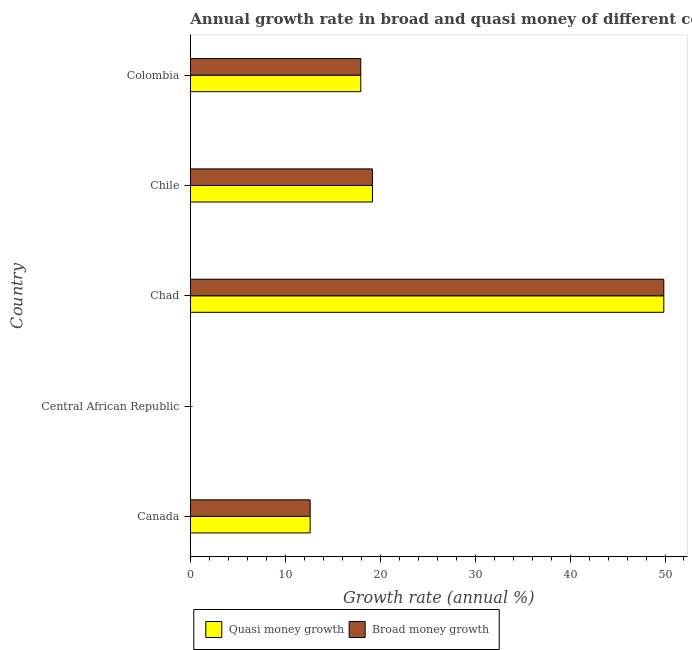Are the number of bars on each tick of the Y-axis equal?
Provide a short and direct response. No. How many bars are there on the 2nd tick from the top?
Keep it short and to the point. 2. What is the label of the 3rd group of bars from the top?
Offer a terse response. Chad. In how many cases, is the number of bars for a given country not equal to the number of legend labels?
Offer a very short reply. 1. What is the annual growth rate in quasi money in Central African Republic?
Give a very brief answer. 0. Across all countries, what is the maximum annual growth rate in broad money?
Make the answer very short. 49.88. In which country was the annual growth rate in quasi money maximum?
Ensure brevity in your answer.  Chad. What is the total annual growth rate in broad money in the graph?
Keep it short and to the point. 99.64. What is the difference between the annual growth rate in broad money in Canada and that in Chad?
Offer a terse response. -37.25. What is the difference between the annual growth rate in quasi money in Colombia and the annual growth rate in broad money in Canada?
Keep it short and to the point. 5.33. What is the average annual growth rate in broad money per country?
Offer a terse response. 19.93. What is the ratio of the annual growth rate in quasi money in Chile to that in Colombia?
Your answer should be very brief. 1.07. Is the annual growth rate in broad money in Canada less than that in Colombia?
Provide a succinct answer. Yes. What is the difference between the highest and the second highest annual growth rate in quasi money?
Offer a terse response. 30.69. What is the difference between the highest and the lowest annual growth rate in quasi money?
Your answer should be compact. 49.88. In how many countries, is the annual growth rate in broad money greater than the average annual growth rate in broad money taken over all countries?
Your answer should be very brief. 1. Is the sum of the annual growth rate in quasi money in Chad and Chile greater than the maximum annual growth rate in broad money across all countries?
Provide a succinct answer. Yes. How many countries are there in the graph?
Offer a terse response. 5. What is the difference between two consecutive major ticks on the X-axis?
Keep it short and to the point. 10. Does the graph contain grids?
Offer a terse response. No. How many legend labels are there?
Your response must be concise. 2. What is the title of the graph?
Ensure brevity in your answer.  Annual growth rate in broad and quasi money of different countries. Does "Passenger Transport Items" appear as one of the legend labels in the graph?
Keep it short and to the point. No. What is the label or title of the X-axis?
Offer a terse response. Growth rate (annual %). What is the Growth rate (annual %) in Quasi money growth in Canada?
Offer a terse response. 12.63. What is the Growth rate (annual %) in Broad money growth in Canada?
Make the answer very short. 12.63. What is the Growth rate (annual %) of Quasi money growth in Central African Republic?
Provide a short and direct response. 0. What is the Growth rate (annual %) in Broad money growth in Central African Republic?
Your response must be concise. 0. What is the Growth rate (annual %) of Quasi money growth in Chad?
Your answer should be compact. 49.88. What is the Growth rate (annual %) of Broad money growth in Chad?
Make the answer very short. 49.88. What is the Growth rate (annual %) in Quasi money growth in Chile?
Your answer should be compact. 19.19. What is the Growth rate (annual %) in Broad money growth in Chile?
Offer a very short reply. 19.19. What is the Growth rate (annual %) of Quasi money growth in Colombia?
Make the answer very short. 17.95. What is the Growth rate (annual %) of Broad money growth in Colombia?
Give a very brief answer. 17.95. Across all countries, what is the maximum Growth rate (annual %) in Quasi money growth?
Provide a short and direct response. 49.88. Across all countries, what is the maximum Growth rate (annual %) in Broad money growth?
Make the answer very short. 49.88. Across all countries, what is the minimum Growth rate (annual %) in Broad money growth?
Provide a short and direct response. 0. What is the total Growth rate (annual %) of Quasi money growth in the graph?
Offer a terse response. 99.64. What is the total Growth rate (annual %) in Broad money growth in the graph?
Offer a terse response. 99.64. What is the difference between the Growth rate (annual %) in Quasi money growth in Canada and that in Chad?
Offer a terse response. -37.25. What is the difference between the Growth rate (annual %) of Broad money growth in Canada and that in Chad?
Your response must be concise. -37.25. What is the difference between the Growth rate (annual %) of Quasi money growth in Canada and that in Chile?
Ensure brevity in your answer.  -6.56. What is the difference between the Growth rate (annual %) of Broad money growth in Canada and that in Chile?
Make the answer very short. -6.56. What is the difference between the Growth rate (annual %) in Quasi money growth in Canada and that in Colombia?
Offer a very short reply. -5.33. What is the difference between the Growth rate (annual %) in Broad money growth in Canada and that in Colombia?
Make the answer very short. -5.33. What is the difference between the Growth rate (annual %) in Quasi money growth in Chad and that in Chile?
Keep it short and to the point. 30.69. What is the difference between the Growth rate (annual %) in Broad money growth in Chad and that in Chile?
Offer a terse response. 30.69. What is the difference between the Growth rate (annual %) in Quasi money growth in Chad and that in Colombia?
Ensure brevity in your answer.  31.92. What is the difference between the Growth rate (annual %) of Broad money growth in Chad and that in Colombia?
Your answer should be compact. 31.92. What is the difference between the Growth rate (annual %) in Quasi money growth in Chile and that in Colombia?
Provide a succinct answer. 1.23. What is the difference between the Growth rate (annual %) of Broad money growth in Chile and that in Colombia?
Your response must be concise. 1.23. What is the difference between the Growth rate (annual %) of Quasi money growth in Canada and the Growth rate (annual %) of Broad money growth in Chad?
Your answer should be very brief. -37.25. What is the difference between the Growth rate (annual %) of Quasi money growth in Canada and the Growth rate (annual %) of Broad money growth in Chile?
Keep it short and to the point. -6.56. What is the difference between the Growth rate (annual %) in Quasi money growth in Canada and the Growth rate (annual %) in Broad money growth in Colombia?
Offer a very short reply. -5.33. What is the difference between the Growth rate (annual %) in Quasi money growth in Chad and the Growth rate (annual %) in Broad money growth in Chile?
Your answer should be very brief. 30.69. What is the difference between the Growth rate (annual %) of Quasi money growth in Chad and the Growth rate (annual %) of Broad money growth in Colombia?
Your answer should be compact. 31.92. What is the difference between the Growth rate (annual %) of Quasi money growth in Chile and the Growth rate (annual %) of Broad money growth in Colombia?
Ensure brevity in your answer.  1.23. What is the average Growth rate (annual %) of Quasi money growth per country?
Keep it short and to the point. 19.93. What is the average Growth rate (annual %) of Broad money growth per country?
Provide a succinct answer. 19.93. What is the difference between the Growth rate (annual %) in Quasi money growth and Growth rate (annual %) in Broad money growth in Canada?
Your response must be concise. 0. What is the difference between the Growth rate (annual %) in Quasi money growth and Growth rate (annual %) in Broad money growth in Chile?
Offer a very short reply. 0. What is the ratio of the Growth rate (annual %) of Quasi money growth in Canada to that in Chad?
Your answer should be very brief. 0.25. What is the ratio of the Growth rate (annual %) of Broad money growth in Canada to that in Chad?
Offer a very short reply. 0.25. What is the ratio of the Growth rate (annual %) in Quasi money growth in Canada to that in Chile?
Keep it short and to the point. 0.66. What is the ratio of the Growth rate (annual %) of Broad money growth in Canada to that in Chile?
Your answer should be very brief. 0.66. What is the ratio of the Growth rate (annual %) in Quasi money growth in Canada to that in Colombia?
Offer a very short reply. 0.7. What is the ratio of the Growth rate (annual %) in Broad money growth in Canada to that in Colombia?
Make the answer very short. 0.7. What is the ratio of the Growth rate (annual %) of Quasi money growth in Chad to that in Chile?
Offer a terse response. 2.6. What is the ratio of the Growth rate (annual %) of Broad money growth in Chad to that in Chile?
Give a very brief answer. 2.6. What is the ratio of the Growth rate (annual %) in Quasi money growth in Chad to that in Colombia?
Offer a very short reply. 2.78. What is the ratio of the Growth rate (annual %) in Broad money growth in Chad to that in Colombia?
Your answer should be compact. 2.78. What is the ratio of the Growth rate (annual %) in Quasi money growth in Chile to that in Colombia?
Your response must be concise. 1.07. What is the ratio of the Growth rate (annual %) in Broad money growth in Chile to that in Colombia?
Make the answer very short. 1.07. What is the difference between the highest and the second highest Growth rate (annual %) of Quasi money growth?
Give a very brief answer. 30.69. What is the difference between the highest and the second highest Growth rate (annual %) of Broad money growth?
Your answer should be compact. 30.69. What is the difference between the highest and the lowest Growth rate (annual %) in Quasi money growth?
Offer a terse response. 49.88. What is the difference between the highest and the lowest Growth rate (annual %) in Broad money growth?
Your response must be concise. 49.88. 